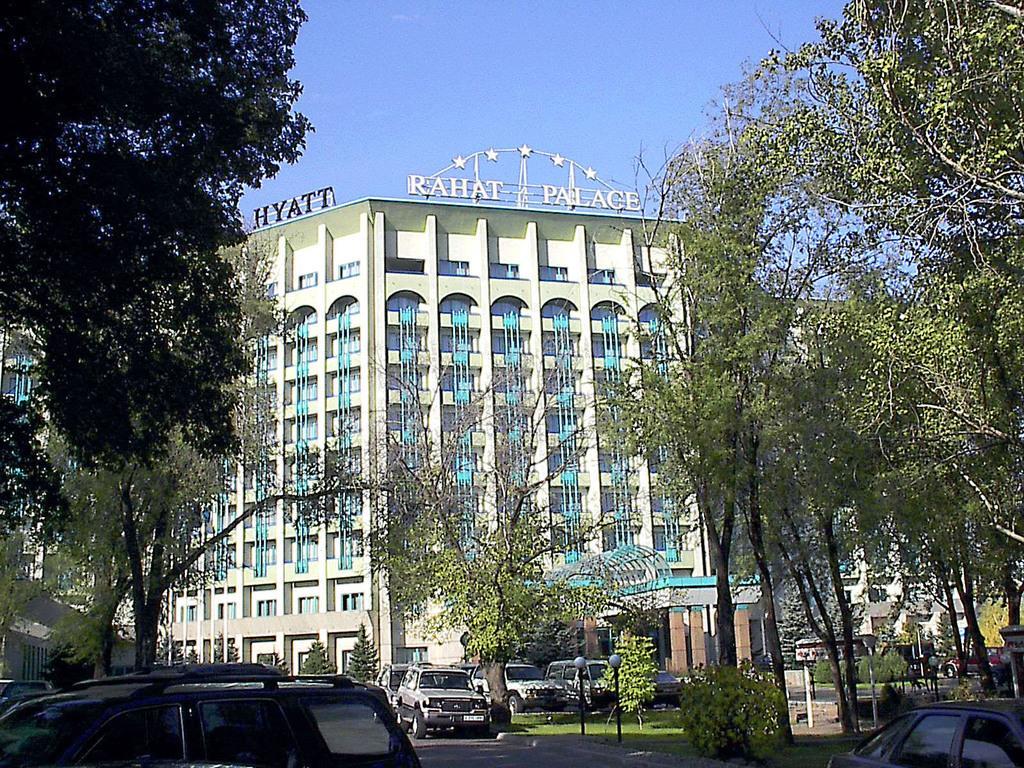Describe this image in one or two sentences. In this image there are cars on the road. There are street lights, plants, trees. In the background of the image there are buildings and sky. 